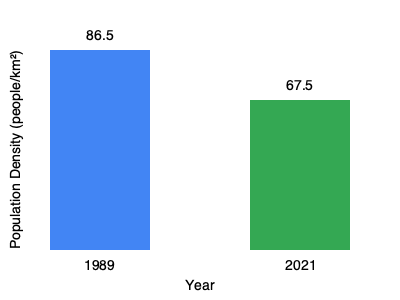Based on the bar graph comparing Ukraine's population density in 1989 (near the end of the Soviet era) and 2021 (30 years after independence), what percentage decrease in population density has Ukraine experienced? To calculate the percentage decrease in population density, we'll follow these steps:

1. Identify the population densities:
   1989 (Soviet era): 86.5 people/km²
   2021 (Post-independence): 67.5 people/km²

2. Calculate the difference:
   $86.5 - 67.5 = 19$ people/km²

3. Calculate the percentage decrease:
   Percentage decrease = $\frac{\text{Decrease}}{\text{Original Value}} \times 100\%$
   
   $= \frac{19}{86.5} \times 100\%$
   
   $= 0.2197 \times 100\%$
   
   $\approx 22\%$

Therefore, the population density of Ukraine has decreased by approximately 22% between 1989 and 2021.
Answer: 22% 